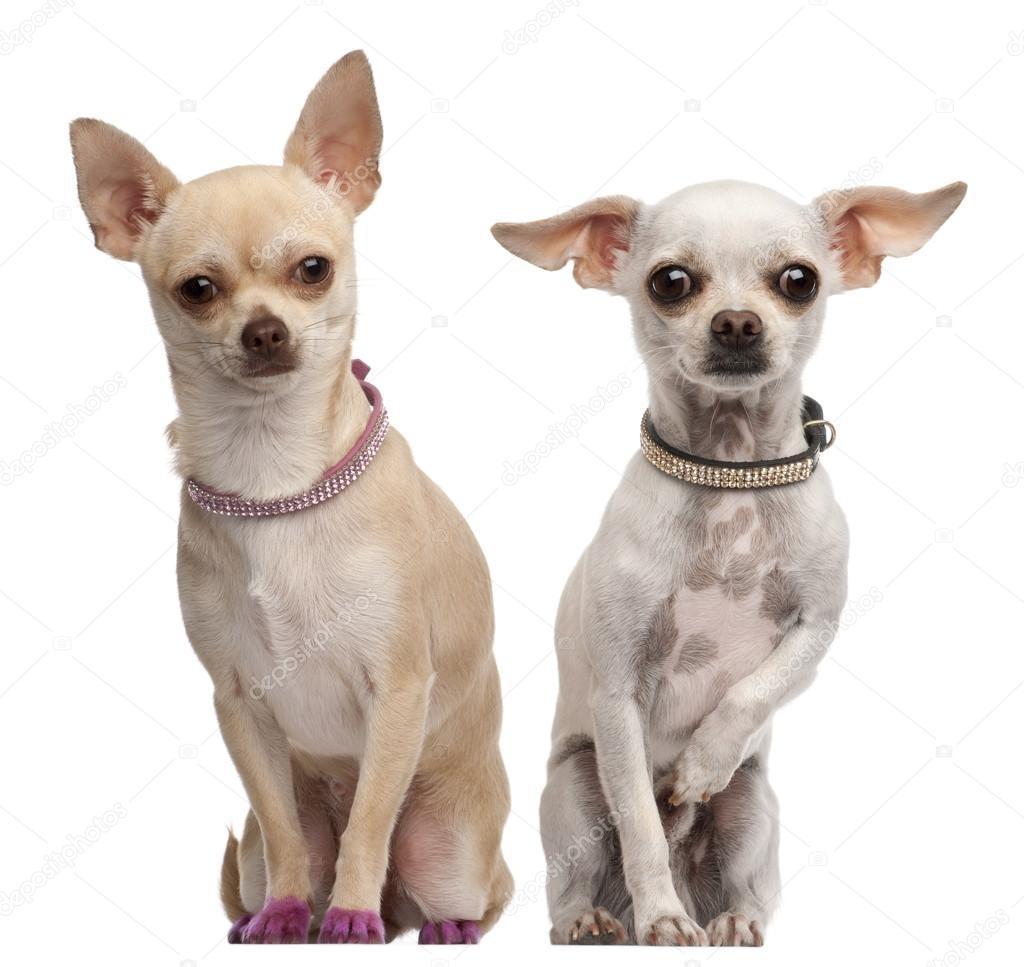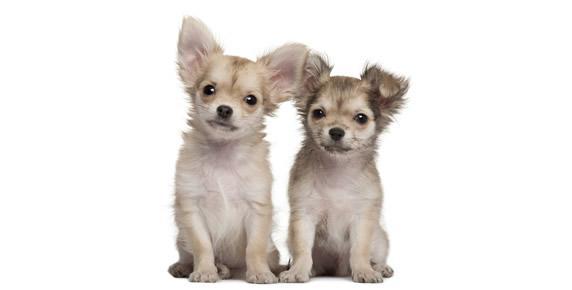The first image is the image on the left, the second image is the image on the right. Analyze the images presented: Is the assertion "Images show a total of four dogs, and all dogs are sitting upright." valid? Answer yes or no. Yes. The first image is the image on the left, the second image is the image on the right. For the images shown, is this caption "One of the images shows a pair of dogs with the white and gray dog holding a paw up." true? Answer yes or no. Yes. 